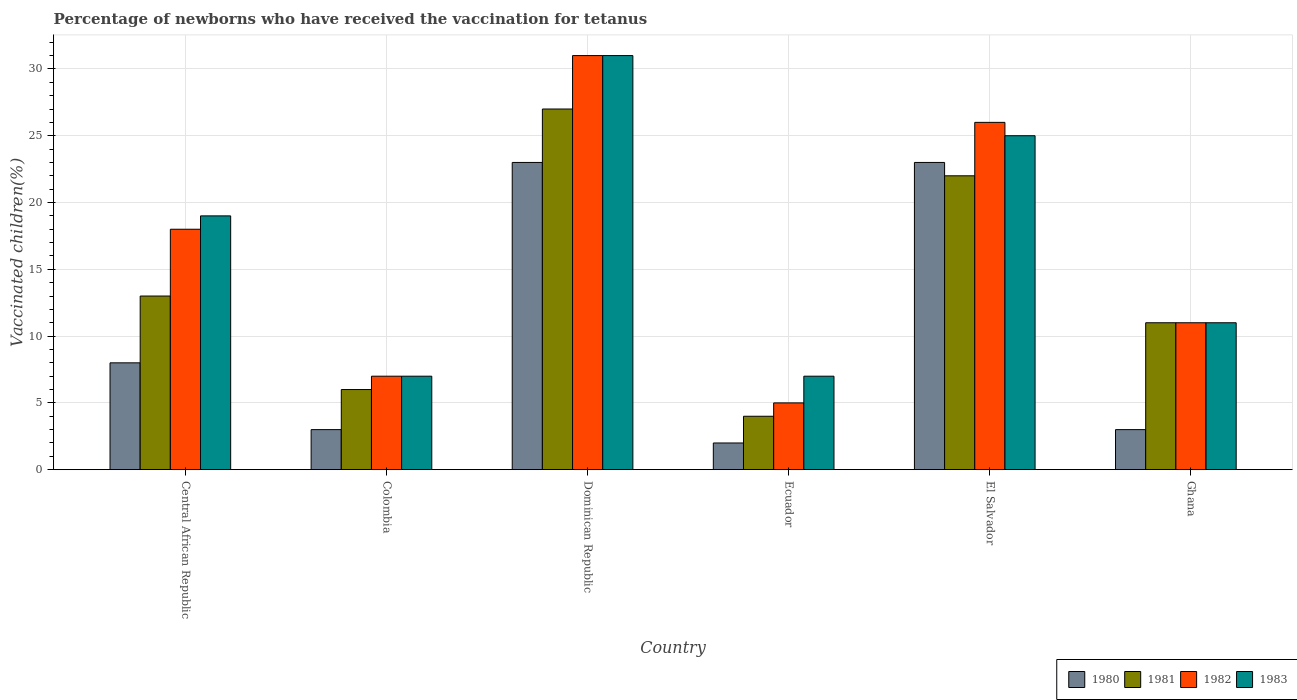How many groups of bars are there?
Ensure brevity in your answer.  6. Are the number of bars per tick equal to the number of legend labels?
Your response must be concise. Yes. Are the number of bars on each tick of the X-axis equal?
Give a very brief answer. Yes. How many bars are there on the 5th tick from the right?
Keep it short and to the point. 4. What is the label of the 4th group of bars from the left?
Make the answer very short. Ecuador. Across all countries, what is the minimum percentage of vaccinated children in 1983?
Offer a terse response. 7. In which country was the percentage of vaccinated children in 1980 maximum?
Keep it short and to the point. Dominican Republic. What is the difference between the percentage of vaccinated children in 1982 in Dominican Republic and the percentage of vaccinated children in 1983 in Central African Republic?
Keep it short and to the point. 12. What is the average percentage of vaccinated children in 1982 per country?
Offer a very short reply. 16.33. In how many countries, is the percentage of vaccinated children in 1982 greater than 3 %?
Your answer should be compact. 6. Is the difference between the percentage of vaccinated children in 1983 in Colombia and Dominican Republic greater than the difference between the percentage of vaccinated children in 1981 in Colombia and Dominican Republic?
Ensure brevity in your answer.  No. What is the difference between the highest and the second highest percentage of vaccinated children in 1982?
Provide a short and direct response. 8. What is the difference between the highest and the lowest percentage of vaccinated children in 1980?
Give a very brief answer. 21. In how many countries, is the percentage of vaccinated children in 1983 greater than the average percentage of vaccinated children in 1983 taken over all countries?
Your answer should be very brief. 3. Is the sum of the percentage of vaccinated children in 1982 in Central African Republic and El Salvador greater than the maximum percentage of vaccinated children in 1981 across all countries?
Give a very brief answer. Yes. What does the 3rd bar from the left in Ghana represents?
Make the answer very short. 1982. What does the 3rd bar from the right in Ecuador represents?
Your response must be concise. 1981. Is it the case that in every country, the sum of the percentage of vaccinated children in 1980 and percentage of vaccinated children in 1981 is greater than the percentage of vaccinated children in 1983?
Provide a short and direct response. No. Are all the bars in the graph horizontal?
Give a very brief answer. No. How many countries are there in the graph?
Give a very brief answer. 6. How many legend labels are there?
Make the answer very short. 4. What is the title of the graph?
Ensure brevity in your answer.  Percentage of newborns who have received the vaccination for tetanus. Does "1964" appear as one of the legend labels in the graph?
Your answer should be very brief. No. What is the label or title of the Y-axis?
Provide a short and direct response. Vaccinated children(%). What is the Vaccinated children(%) of 1980 in Central African Republic?
Keep it short and to the point. 8. What is the Vaccinated children(%) in 1982 in Central African Republic?
Offer a very short reply. 18. What is the Vaccinated children(%) of 1983 in Central African Republic?
Your response must be concise. 19. What is the Vaccinated children(%) of 1980 in Colombia?
Make the answer very short. 3. What is the Vaccinated children(%) in 1982 in Colombia?
Your answer should be very brief. 7. What is the Vaccinated children(%) in 1980 in Dominican Republic?
Offer a very short reply. 23. What is the Vaccinated children(%) of 1981 in Dominican Republic?
Offer a very short reply. 27. What is the Vaccinated children(%) of 1981 in Ecuador?
Your answer should be compact. 4. What is the Vaccinated children(%) of 1982 in Ecuador?
Your answer should be compact. 5. What is the Vaccinated children(%) of 1983 in El Salvador?
Offer a very short reply. 25. What is the Vaccinated children(%) in 1981 in Ghana?
Give a very brief answer. 11. What is the Vaccinated children(%) of 1982 in Ghana?
Ensure brevity in your answer.  11. What is the Vaccinated children(%) of 1983 in Ghana?
Offer a very short reply. 11. Across all countries, what is the maximum Vaccinated children(%) in 1980?
Your response must be concise. 23. Across all countries, what is the maximum Vaccinated children(%) in 1981?
Your answer should be very brief. 27. Across all countries, what is the minimum Vaccinated children(%) of 1982?
Offer a very short reply. 5. Across all countries, what is the minimum Vaccinated children(%) in 1983?
Your answer should be compact. 7. What is the total Vaccinated children(%) in 1980 in the graph?
Keep it short and to the point. 62. What is the total Vaccinated children(%) of 1981 in the graph?
Offer a very short reply. 83. What is the difference between the Vaccinated children(%) of 1980 in Central African Republic and that in Dominican Republic?
Provide a short and direct response. -15. What is the difference between the Vaccinated children(%) in 1982 in Central African Republic and that in Dominican Republic?
Keep it short and to the point. -13. What is the difference between the Vaccinated children(%) in 1980 in Central African Republic and that in Ecuador?
Keep it short and to the point. 6. What is the difference between the Vaccinated children(%) in 1982 in Central African Republic and that in Ecuador?
Offer a terse response. 13. What is the difference between the Vaccinated children(%) of 1983 in Central African Republic and that in Ecuador?
Offer a very short reply. 12. What is the difference between the Vaccinated children(%) of 1980 in Central African Republic and that in El Salvador?
Keep it short and to the point. -15. What is the difference between the Vaccinated children(%) in 1981 in Central African Republic and that in El Salvador?
Offer a very short reply. -9. What is the difference between the Vaccinated children(%) of 1982 in Central African Republic and that in El Salvador?
Offer a very short reply. -8. What is the difference between the Vaccinated children(%) in 1983 in Central African Republic and that in El Salvador?
Provide a short and direct response. -6. What is the difference between the Vaccinated children(%) in 1980 in Central African Republic and that in Ghana?
Provide a short and direct response. 5. What is the difference between the Vaccinated children(%) in 1981 in Central African Republic and that in Ghana?
Ensure brevity in your answer.  2. What is the difference between the Vaccinated children(%) of 1982 in Central African Republic and that in Ghana?
Offer a very short reply. 7. What is the difference between the Vaccinated children(%) in 1983 in Central African Republic and that in Ghana?
Ensure brevity in your answer.  8. What is the difference between the Vaccinated children(%) of 1980 in Colombia and that in Dominican Republic?
Offer a very short reply. -20. What is the difference between the Vaccinated children(%) of 1981 in Colombia and that in Dominican Republic?
Your response must be concise. -21. What is the difference between the Vaccinated children(%) of 1983 in Colombia and that in Dominican Republic?
Provide a short and direct response. -24. What is the difference between the Vaccinated children(%) in 1980 in Colombia and that in Ecuador?
Give a very brief answer. 1. What is the difference between the Vaccinated children(%) in 1981 in Colombia and that in Ecuador?
Make the answer very short. 2. What is the difference between the Vaccinated children(%) in 1982 in Colombia and that in Ecuador?
Offer a terse response. 2. What is the difference between the Vaccinated children(%) in 1981 in Colombia and that in El Salvador?
Keep it short and to the point. -16. What is the difference between the Vaccinated children(%) of 1982 in Colombia and that in El Salvador?
Make the answer very short. -19. What is the difference between the Vaccinated children(%) of 1981 in Colombia and that in Ghana?
Offer a very short reply. -5. What is the difference between the Vaccinated children(%) in 1981 in Dominican Republic and that in Ecuador?
Make the answer very short. 23. What is the difference between the Vaccinated children(%) in 1980 in Dominican Republic and that in El Salvador?
Keep it short and to the point. 0. What is the difference between the Vaccinated children(%) in 1981 in Dominican Republic and that in El Salvador?
Provide a short and direct response. 5. What is the difference between the Vaccinated children(%) in 1983 in Dominican Republic and that in Ghana?
Your answer should be very brief. 20. What is the difference between the Vaccinated children(%) of 1981 in Ecuador and that in El Salvador?
Provide a short and direct response. -18. What is the difference between the Vaccinated children(%) in 1981 in Ecuador and that in Ghana?
Your answer should be compact. -7. What is the difference between the Vaccinated children(%) of 1982 in Ecuador and that in Ghana?
Your answer should be compact. -6. What is the difference between the Vaccinated children(%) of 1980 in El Salvador and that in Ghana?
Give a very brief answer. 20. What is the difference between the Vaccinated children(%) of 1981 in El Salvador and that in Ghana?
Your answer should be compact. 11. What is the difference between the Vaccinated children(%) in 1982 in El Salvador and that in Ghana?
Your response must be concise. 15. What is the difference between the Vaccinated children(%) of 1980 in Central African Republic and the Vaccinated children(%) of 1981 in Colombia?
Your answer should be compact. 2. What is the difference between the Vaccinated children(%) in 1980 in Central African Republic and the Vaccinated children(%) in 1982 in Colombia?
Offer a terse response. 1. What is the difference between the Vaccinated children(%) of 1980 in Central African Republic and the Vaccinated children(%) of 1983 in Colombia?
Offer a terse response. 1. What is the difference between the Vaccinated children(%) of 1981 in Central African Republic and the Vaccinated children(%) of 1982 in Colombia?
Keep it short and to the point. 6. What is the difference between the Vaccinated children(%) in 1980 in Central African Republic and the Vaccinated children(%) in 1982 in Dominican Republic?
Your answer should be very brief. -23. What is the difference between the Vaccinated children(%) of 1981 in Central African Republic and the Vaccinated children(%) of 1982 in Dominican Republic?
Your answer should be very brief. -18. What is the difference between the Vaccinated children(%) of 1981 in Central African Republic and the Vaccinated children(%) of 1983 in Dominican Republic?
Give a very brief answer. -18. What is the difference between the Vaccinated children(%) of 1982 in Central African Republic and the Vaccinated children(%) of 1983 in Dominican Republic?
Your answer should be very brief. -13. What is the difference between the Vaccinated children(%) of 1980 in Central African Republic and the Vaccinated children(%) of 1981 in Ecuador?
Your answer should be compact. 4. What is the difference between the Vaccinated children(%) of 1980 in Central African Republic and the Vaccinated children(%) of 1982 in Ecuador?
Offer a terse response. 3. What is the difference between the Vaccinated children(%) of 1980 in Central African Republic and the Vaccinated children(%) of 1983 in Ecuador?
Give a very brief answer. 1. What is the difference between the Vaccinated children(%) in 1981 in Central African Republic and the Vaccinated children(%) in 1982 in Ecuador?
Your answer should be compact. 8. What is the difference between the Vaccinated children(%) of 1982 in Central African Republic and the Vaccinated children(%) of 1983 in Ecuador?
Provide a succinct answer. 11. What is the difference between the Vaccinated children(%) of 1980 in Central African Republic and the Vaccinated children(%) of 1981 in El Salvador?
Keep it short and to the point. -14. What is the difference between the Vaccinated children(%) in 1980 in Central African Republic and the Vaccinated children(%) in 1982 in El Salvador?
Provide a short and direct response. -18. What is the difference between the Vaccinated children(%) in 1980 in Central African Republic and the Vaccinated children(%) in 1983 in El Salvador?
Your answer should be compact. -17. What is the difference between the Vaccinated children(%) of 1981 in Central African Republic and the Vaccinated children(%) of 1982 in El Salvador?
Provide a succinct answer. -13. What is the difference between the Vaccinated children(%) of 1981 in Central African Republic and the Vaccinated children(%) of 1982 in Ghana?
Give a very brief answer. 2. What is the difference between the Vaccinated children(%) in 1981 in Central African Republic and the Vaccinated children(%) in 1983 in Ghana?
Your answer should be compact. 2. What is the difference between the Vaccinated children(%) of 1982 in Central African Republic and the Vaccinated children(%) of 1983 in Ghana?
Provide a succinct answer. 7. What is the difference between the Vaccinated children(%) of 1981 in Colombia and the Vaccinated children(%) of 1982 in Dominican Republic?
Offer a terse response. -25. What is the difference between the Vaccinated children(%) of 1981 in Colombia and the Vaccinated children(%) of 1983 in Dominican Republic?
Give a very brief answer. -25. What is the difference between the Vaccinated children(%) of 1982 in Colombia and the Vaccinated children(%) of 1983 in Dominican Republic?
Ensure brevity in your answer.  -24. What is the difference between the Vaccinated children(%) of 1980 in Colombia and the Vaccinated children(%) of 1983 in Ecuador?
Your answer should be compact. -4. What is the difference between the Vaccinated children(%) of 1981 in Colombia and the Vaccinated children(%) of 1983 in Ecuador?
Make the answer very short. -1. What is the difference between the Vaccinated children(%) in 1980 in Colombia and the Vaccinated children(%) in 1981 in El Salvador?
Make the answer very short. -19. What is the difference between the Vaccinated children(%) of 1980 in Colombia and the Vaccinated children(%) of 1983 in El Salvador?
Provide a short and direct response. -22. What is the difference between the Vaccinated children(%) in 1981 in Colombia and the Vaccinated children(%) in 1982 in El Salvador?
Your answer should be compact. -20. What is the difference between the Vaccinated children(%) in 1982 in Colombia and the Vaccinated children(%) in 1983 in El Salvador?
Your answer should be compact. -18. What is the difference between the Vaccinated children(%) in 1981 in Colombia and the Vaccinated children(%) in 1982 in Ghana?
Keep it short and to the point. -5. What is the difference between the Vaccinated children(%) of 1981 in Colombia and the Vaccinated children(%) of 1983 in Ghana?
Keep it short and to the point. -5. What is the difference between the Vaccinated children(%) in 1982 in Colombia and the Vaccinated children(%) in 1983 in Ghana?
Your response must be concise. -4. What is the difference between the Vaccinated children(%) of 1980 in Dominican Republic and the Vaccinated children(%) of 1983 in Ecuador?
Your answer should be compact. 16. What is the difference between the Vaccinated children(%) in 1982 in Dominican Republic and the Vaccinated children(%) in 1983 in Ecuador?
Offer a very short reply. 24. What is the difference between the Vaccinated children(%) in 1980 in Dominican Republic and the Vaccinated children(%) in 1983 in El Salvador?
Ensure brevity in your answer.  -2. What is the difference between the Vaccinated children(%) of 1981 in Dominican Republic and the Vaccinated children(%) of 1982 in El Salvador?
Give a very brief answer. 1. What is the difference between the Vaccinated children(%) of 1982 in Dominican Republic and the Vaccinated children(%) of 1983 in El Salvador?
Give a very brief answer. 6. What is the difference between the Vaccinated children(%) in 1980 in Dominican Republic and the Vaccinated children(%) in 1981 in Ghana?
Make the answer very short. 12. What is the difference between the Vaccinated children(%) of 1980 in Dominican Republic and the Vaccinated children(%) of 1982 in Ghana?
Your answer should be very brief. 12. What is the difference between the Vaccinated children(%) of 1981 in Dominican Republic and the Vaccinated children(%) of 1983 in Ghana?
Offer a very short reply. 16. What is the difference between the Vaccinated children(%) of 1980 in Ecuador and the Vaccinated children(%) of 1981 in El Salvador?
Your answer should be compact. -20. What is the difference between the Vaccinated children(%) in 1980 in Ecuador and the Vaccinated children(%) in 1983 in El Salvador?
Ensure brevity in your answer.  -23. What is the difference between the Vaccinated children(%) of 1981 in Ecuador and the Vaccinated children(%) of 1983 in El Salvador?
Provide a short and direct response. -21. What is the difference between the Vaccinated children(%) in 1982 in Ecuador and the Vaccinated children(%) in 1983 in El Salvador?
Your answer should be very brief. -20. What is the difference between the Vaccinated children(%) in 1980 in Ecuador and the Vaccinated children(%) in 1981 in Ghana?
Offer a terse response. -9. What is the difference between the Vaccinated children(%) of 1980 in Ecuador and the Vaccinated children(%) of 1982 in Ghana?
Keep it short and to the point. -9. What is the difference between the Vaccinated children(%) in 1982 in Ecuador and the Vaccinated children(%) in 1983 in Ghana?
Ensure brevity in your answer.  -6. What is the difference between the Vaccinated children(%) in 1980 in El Salvador and the Vaccinated children(%) in 1981 in Ghana?
Keep it short and to the point. 12. What is the difference between the Vaccinated children(%) in 1980 in El Salvador and the Vaccinated children(%) in 1983 in Ghana?
Your answer should be very brief. 12. What is the difference between the Vaccinated children(%) in 1981 in El Salvador and the Vaccinated children(%) in 1983 in Ghana?
Offer a very short reply. 11. What is the average Vaccinated children(%) in 1980 per country?
Your response must be concise. 10.33. What is the average Vaccinated children(%) of 1981 per country?
Provide a short and direct response. 13.83. What is the average Vaccinated children(%) in 1982 per country?
Keep it short and to the point. 16.33. What is the average Vaccinated children(%) in 1983 per country?
Provide a succinct answer. 16.67. What is the difference between the Vaccinated children(%) in 1980 and Vaccinated children(%) in 1981 in Central African Republic?
Make the answer very short. -5. What is the difference between the Vaccinated children(%) in 1980 and Vaccinated children(%) in 1982 in Central African Republic?
Offer a terse response. -10. What is the difference between the Vaccinated children(%) of 1980 and Vaccinated children(%) of 1983 in Central African Republic?
Provide a short and direct response. -11. What is the difference between the Vaccinated children(%) of 1981 and Vaccinated children(%) of 1982 in Central African Republic?
Offer a very short reply. -5. What is the difference between the Vaccinated children(%) in 1981 and Vaccinated children(%) in 1983 in Central African Republic?
Your answer should be compact. -6. What is the difference between the Vaccinated children(%) in 1982 and Vaccinated children(%) in 1983 in Central African Republic?
Give a very brief answer. -1. What is the difference between the Vaccinated children(%) of 1980 and Vaccinated children(%) of 1981 in Colombia?
Your answer should be very brief. -3. What is the difference between the Vaccinated children(%) of 1980 and Vaccinated children(%) of 1982 in Colombia?
Provide a short and direct response. -4. What is the difference between the Vaccinated children(%) in 1981 and Vaccinated children(%) in 1983 in Colombia?
Make the answer very short. -1. What is the difference between the Vaccinated children(%) in 1980 and Vaccinated children(%) in 1981 in Dominican Republic?
Offer a very short reply. -4. What is the difference between the Vaccinated children(%) in 1980 and Vaccinated children(%) in 1982 in Dominican Republic?
Keep it short and to the point. -8. What is the difference between the Vaccinated children(%) of 1981 and Vaccinated children(%) of 1982 in Dominican Republic?
Provide a short and direct response. -4. What is the difference between the Vaccinated children(%) of 1982 and Vaccinated children(%) of 1983 in Dominican Republic?
Ensure brevity in your answer.  0. What is the difference between the Vaccinated children(%) in 1980 and Vaccinated children(%) in 1982 in Ecuador?
Your answer should be compact. -3. What is the difference between the Vaccinated children(%) in 1980 and Vaccinated children(%) in 1983 in Ecuador?
Give a very brief answer. -5. What is the difference between the Vaccinated children(%) in 1981 and Vaccinated children(%) in 1983 in Ecuador?
Keep it short and to the point. -3. What is the difference between the Vaccinated children(%) in 1982 and Vaccinated children(%) in 1983 in Ecuador?
Provide a short and direct response. -2. What is the difference between the Vaccinated children(%) in 1980 and Vaccinated children(%) in 1982 in El Salvador?
Offer a very short reply. -3. What is the difference between the Vaccinated children(%) in 1981 and Vaccinated children(%) in 1982 in El Salvador?
Your answer should be compact. -4. What is the difference between the Vaccinated children(%) of 1981 and Vaccinated children(%) of 1983 in El Salvador?
Provide a short and direct response. -3. What is the difference between the Vaccinated children(%) of 1980 and Vaccinated children(%) of 1982 in Ghana?
Offer a terse response. -8. What is the difference between the Vaccinated children(%) in 1981 and Vaccinated children(%) in 1983 in Ghana?
Offer a terse response. 0. What is the difference between the Vaccinated children(%) in 1982 and Vaccinated children(%) in 1983 in Ghana?
Provide a succinct answer. 0. What is the ratio of the Vaccinated children(%) in 1980 in Central African Republic to that in Colombia?
Make the answer very short. 2.67. What is the ratio of the Vaccinated children(%) in 1981 in Central African Republic to that in Colombia?
Provide a succinct answer. 2.17. What is the ratio of the Vaccinated children(%) in 1982 in Central African Republic to that in Colombia?
Keep it short and to the point. 2.57. What is the ratio of the Vaccinated children(%) of 1983 in Central African Republic to that in Colombia?
Give a very brief answer. 2.71. What is the ratio of the Vaccinated children(%) of 1980 in Central African Republic to that in Dominican Republic?
Your answer should be very brief. 0.35. What is the ratio of the Vaccinated children(%) in 1981 in Central African Republic to that in Dominican Republic?
Keep it short and to the point. 0.48. What is the ratio of the Vaccinated children(%) of 1982 in Central African Republic to that in Dominican Republic?
Offer a very short reply. 0.58. What is the ratio of the Vaccinated children(%) of 1983 in Central African Republic to that in Dominican Republic?
Make the answer very short. 0.61. What is the ratio of the Vaccinated children(%) of 1981 in Central African Republic to that in Ecuador?
Keep it short and to the point. 3.25. What is the ratio of the Vaccinated children(%) in 1983 in Central African Republic to that in Ecuador?
Provide a succinct answer. 2.71. What is the ratio of the Vaccinated children(%) in 1980 in Central African Republic to that in El Salvador?
Provide a short and direct response. 0.35. What is the ratio of the Vaccinated children(%) of 1981 in Central African Republic to that in El Salvador?
Your answer should be compact. 0.59. What is the ratio of the Vaccinated children(%) in 1982 in Central African Republic to that in El Salvador?
Your response must be concise. 0.69. What is the ratio of the Vaccinated children(%) in 1983 in Central African Republic to that in El Salvador?
Your answer should be very brief. 0.76. What is the ratio of the Vaccinated children(%) of 1980 in Central African Republic to that in Ghana?
Give a very brief answer. 2.67. What is the ratio of the Vaccinated children(%) of 1981 in Central African Republic to that in Ghana?
Provide a succinct answer. 1.18. What is the ratio of the Vaccinated children(%) of 1982 in Central African Republic to that in Ghana?
Your answer should be compact. 1.64. What is the ratio of the Vaccinated children(%) of 1983 in Central African Republic to that in Ghana?
Offer a very short reply. 1.73. What is the ratio of the Vaccinated children(%) in 1980 in Colombia to that in Dominican Republic?
Give a very brief answer. 0.13. What is the ratio of the Vaccinated children(%) of 1981 in Colombia to that in Dominican Republic?
Your response must be concise. 0.22. What is the ratio of the Vaccinated children(%) of 1982 in Colombia to that in Dominican Republic?
Your answer should be compact. 0.23. What is the ratio of the Vaccinated children(%) in 1983 in Colombia to that in Dominican Republic?
Your answer should be very brief. 0.23. What is the ratio of the Vaccinated children(%) in 1980 in Colombia to that in Ecuador?
Your answer should be compact. 1.5. What is the ratio of the Vaccinated children(%) of 1982 in Colombia to that in Ecuador?
Ensure brevity in your answer.  1.4. What is the ratio of the Vaccinated children(%) of 1980 in Colombia to that in El Salvador?
Keep it short and to the point. 0.13. What is the ratio of the Vaccinated children(%) in 1981 in Colombia to that in El Salvador?
Your answer should be very brief. 0.27. What is the ratio of the Vaccinated children(%) of 1982 in Colombia to that in El Salvador?
Your answer should be very brief. 0.27. What is the ratio of the Vaccinated children(%) of 1983 in Colombia to that in El Salvador?
Ensure brevity in your answer.  0.28. What is the ratio of the Vaccinated children(%) in 1981 in Colombia to that in Ghana?
Your answer should be compact. 0.55. What is the ratio of the Vaccinated children(%) of 1982 in Colombia to that in Ghana?
Make the answer very short. 0.64. What is the ratio of the Vaccinated children(%) of 1983 in Colombia to that in Ghana?
Your answer should be compact. 0.64. What is the ratio of the Vaccinated children(%) in 1980 in Dominican Republic to that in Ecuador?
Your answer should be very brief. 11.5. What is the ratio of the Vaccinated children(%) of 1981 in Dominican Republic to that in Ecuador?
Offer a very short reply. 6.75. What is the ratio of the Vaccinated children(%) in 1982 in Dominican Republic to that in Ecuador?
Offer a terse response. 6.2. What is the ratio of the Vaccinated children(%) in 1983 in Dominican Republic to that in Ecuador?
Your answer should be very brief. 4.43. What is the ratio of the Vaccinated children(%) in 1981 in Dominican Republic to that in El Salvador?
Offer a terse response. 1.23. What is the ratio of the Vaccinated children(%) of 1982 in Dominican Republic to that in El Salvador?
Your answer should be very brief. 1.19. What is the ratio of the Vaccinated children(%) of 1983 in Dominican Republic to that in El Salvador?
Provide a short and direct response. 1.24. What is the ratio of the Vaccinated children(%) in 1980 in Dominican Republic to that in Ghana?
Your response must be concise. 7.67. What is the ratio of the Vaccinated children(%) in 1981 in Dominican Republic to that in Ghana?
Provide a short and direct response. 2.45. What is the ratio of the Vaccinated children(%) of 1982 in Dominican Republic to that in Ghana?
Keep it short and to the point. 2.82. What is the ratio of the Vaccinated children(%) in 1983 in Dominican Republic to that in Ghana?
Offer a very short reply. 2.82. What is the ratio of the Vaccinated children(%) of 1980 in Ecuador to that in El Salvador?
Make the answer very short. 0.09. What is the ratio of the Vaccinated children(%) of 1981 in Ecuador to that in El Salvador?
Your answer should be very brief. 0.18. What is the ratio of the Vaccinated children(%) of 1982 in Ecuador to that in El Salvador?
Offer a very short reply. 0.19. What is the ratio of the Vaccinated children(%) of 1983 in Ecuador to that in El Salvador?
Offer a very short reply. 0.28. What is the ratio of the Vaccinated children(%) of 1981 in Ecuador to that in Ghana?
Give a very brief answer. 0.36. What is the ratio of the Vaccinated children(%) in 1982 in Ecuador to that in Ghana?
Offer a very short reply. 0.45. What is the ratio of the Vaccinated children(%) of 1983 in Ecuador to that in Ghana?
Keep it short and to the point. 0.64. What is the ratio of the Vaccinated children(%) in 1980 in El Salvador to that in Ghana?
Your response must be concise. 7.67. What is the ratio of the Vaccinated children(%) in 1982 in El Salvador to that in Ghana?
Provide a succinct answer. 2.36. What is the ratio of the Vaccinated children(%) in 1983 in El Salvador to that in Ghana?
Your answer should be compact. 2.27. What is the difference between the highest and the second highest Vaccinated children(%) in 1980?
Keep it short and to the point. 0. What is the difference between the highest and the second highest Vaccinated children(%) of 1982?
Keep it short and to the point. 5. What is the difference between the highest and the second highest Vaccinated children(%) in 1983?
Ensure brevity in your answer.  6. What is the difference between the highest and the lowest Vaccinated children(%) of 1983?
Keep it short and to the point. 24. 